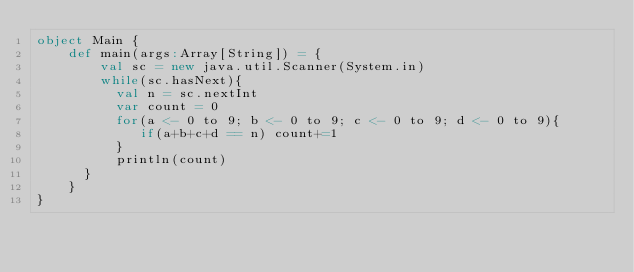<code> <loc_0><loc_0><loc_500><loc_500><_Scala_>object Main {
    def main(args:Array[String]) = {
        val sc = new java.util.Scanner(System.in)
        while(sc.hasNext){
	        val n = sc.nextInt
	        var count = 0
	        for(a <- 0 to 9; b <- 0 to 9; c <- 0 to 9; d <- 0 to 9){
	           if(a+b+c+d == n) count+=1
	        }
	        println(count)
    	}
    }
}</code> 